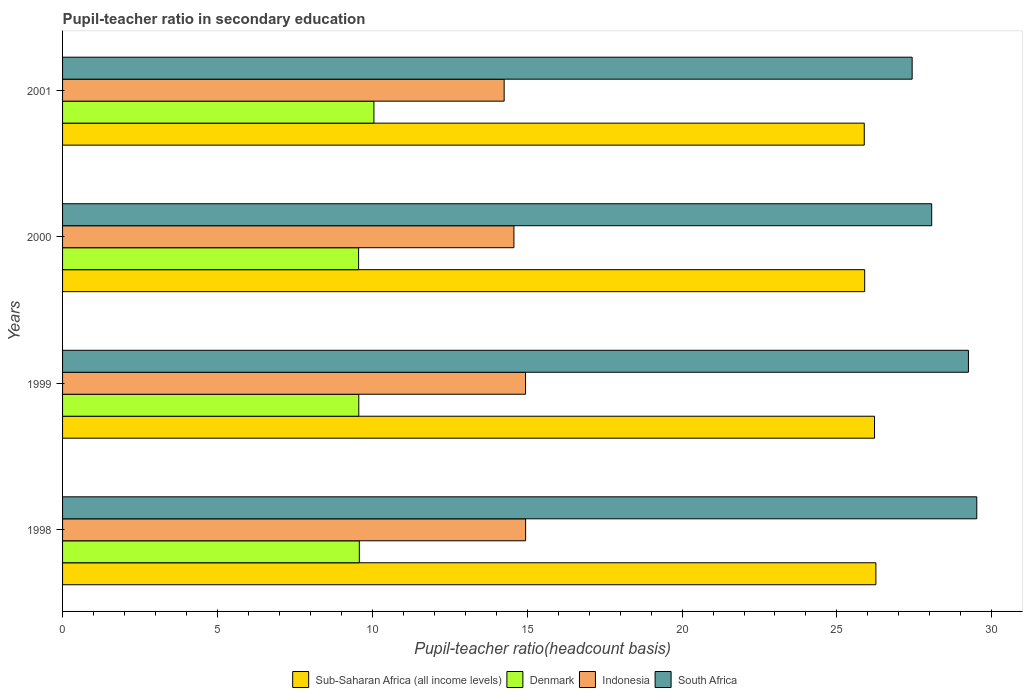How many groups of bars are there?
Keep it short and to the point. 4. Are the number of bars on each tick of the Y-axis equal?
Make the answer very short. Yes. How many bars are there on the 4th tick from the top?
Offer a terse response. 4. How many bars are there on the 2nd tick from the bottom?
Offer a terse response. 4. What is the pupil-teacher ratio in secondary education in Sub-Saharan Africa (all income levels) in 2001?
Provide a succinct answer. 25.88. Across all years, what is the maximum pupil-teacher ratio in secondary education in Indonesia?
Provide a succinct answer. 14.95. Across all years, what is the minimum pupil-teacher ratio in secondary education in Denmark?
Make the answer very short. 9.56. In which year was the pupil-teacher ratio in secondary education in Sub-Saharan Africa (all income levels) maximum?
Your answer should be compact. 1998. What is the total pupil-teacher ratio in secondary education in South Africa in the graph?
Provide a succinct answer. 114.25. What is the difference between the pupil-teacher ratio in secondary education in Sub-Saharan Africa (all income levels) in 1998 and that in 2000?
Make the answer very short. 0.36. What is the difference between the pupil-teacher ratio in secondary education in Indonesia in 2000 and the pupil-teacher ratio in secondary education in South Africa in 2001?
Provide a short and direct response. -12.86. What is the average pupil-teacher ratio in secondary education in Denmark per year?
Your answer should be compact. 9.69. In the year 1999, what is the difference between the pupil-teacher ratio in secondary education in South Africa and pupil-teacher ratio in secondary education in Sub-Saharan Africa (all income levels)?
Your answer should be very brief. 3.03. In how many years, is the pupil-teacher ratio in secondary education in Indonesia greater than 27 ?
Give a very brief answer. 0. What is the ratio of the pupil-teacher ratio in secondary education in Indonesia in 1998 to that in 2000?
Your answer should be very brief. 1.03. Is the pupil-teacher ratio in secondary education in Indonesia in 1999 less than that in 2000?
Offer a terse response. No. What is the difference between the highest and the second highest pupil-teacher ratio in secondary education in South Africa?
Ensure brevity in your answer.  0.27. What is the difference between the highest and the lowest pupil-teacher ratio in secondary education in Sub-Saharan Africa (all income levels)?
Your answer should be compact. 0.38. In how many years, is the pupil-teacher ratio in secondary education in Indonesia greater than the average pupil-teacher ratio in secondary education in Indonesia taken over all years?
Offer a terse response. 2. What does the 4th bar from the top in 2000 represents?
Ensure brevity in your answer.  Sub-Saharan Africa (all income levels). What does the 4th bar from the bottom in 2001 represents?
Your answer should be compact. South Africa. Is it the case that in every year, the sum of the pupil-teacher ratio in secondary education in Denmark and pupil-teacher ratio in secondary education in Sub-Saharan Africa (all income levels) is greater than the pupil-teacher ratio in secondary education in South Africa?
Provide a short and direct response. Yes. How many years are there in the graph?
Your answer should be very brief. 4. What is the difference between two consecutive major ticks on the X-axis?
Your response must be concise. 5. Are the values on the major ticks of X-axis written in scientific E-notation?
Offer a very short reply. No. How many legend labels are there?
Keep it short and to the point. 4. How are the legend labels stacked?
Your answer should be compact. Horizontal. What is the title of the graph?
Your answer should be very brief. Pupil-teacher ratio in secondary education. What is the label or title of the X-axis?
Make the answer very short. Pupil-teacher ratio(headcount basis). What is the Pupil-teacher ratio(headcount basis) of Sub-Saharan Africa (all income levels) in 1998?
Your answer should be very brief. 26.26. What is the Pupil-teacher ratio(headcount basis) of Denmark in 1998?
Your response must be concise. 9.58. What is the Pupil-teacher ratio(headcount basis) in Indonesia in 1998?
Your answer should be compact. 14.95. What is the Pupil-teacher ratio(headcount basis) in South Africa in 1998?
Your response must be concise. 29.52. What is the Pupil-teacher ratio(headcount basis) of Sub-Saharan Africa (all income levels) in 1999?
Your answer should be compact. 26.21. What is the Pupil-teacher ratio(headcount basis) in Denmark in 1999?
Give a very brief answer. 9.56. What is the Pupil-teacher ratio(headcount basis) in Indonesia in 1999?
Offer a terse response. 14.95. What is the Pupil-teacher ratio(headcount basis) in South Africa in 1999?
Your answer should be compact. 29.25. What is the Pupil-teacher ratio(headcount basis) of Sub-Saharan Africa (all income levels) in 2000?
Give a very brief answer. 25.9. What is the Pupil-teacher ratio(headcount basis) in Denmark in 2000?
Your response must be concise. 9.56. What is the Pupil-teacher ratio(headcount basis) of Indonesia in 2000?
Ensure brevity in your answer.  14.57. What is the Pupil-teacher ratio(headcount basis) of South Africa in 2000?
Provide a succinct answer. 28.06. What is the Pupil-teacher ratio(headcount basis) in Sub-Saharan Africa (all income levels) in 2001?
Offer a very short reply. 25.88. What is the Pupil-teacher ratio(headcount basis) in Denmark in 2001?
Keep it short and to the point. 10.05. What is the Pupil-teacher ratio(headcount basis) in Indonesia in 2001?
Keep it short and to the point. 14.26. What is the Pupil-teacher ratio(headcount basis) of South Africa in 2001?
Offer a terse response. 27.43. Across all years, what is the maximum Pupil-teacher ratio(headcount basis) in Sub-Saharan Africa (all income levels)?
Keep it short and to the point. 26.26. Across all years, what is the maximum Pupil-teacher ratio(headcount basis) of Denmark?
Keep it short and to the point. 10.05. Across all years, what is the maximum Pupil-teacher ratio(headcount basis) of Indonesia?
Your answer should be very brief. 14.95. Across all years, what is the maximum Pupil-teacher ratio(headcount basis) of South Africa?
Your response must be concise. 29.52. Across all years, what is the minimum Pupil-teacher ratio(headcount basis) in Sub-Saharan Africa (all income levels)?
Ensure brevity in your answer.  25.88. Across all years, what is the minimum Pupil-teacher ratio(headcount basis) in Denmark?
Provide a short and direct response. 9.56. Across all years, what is the minimum Pupil-teacher ratio(headcount basis) in Indonesia?
Make the answer very short. 14.26. Across all years, what is the minimum Pupil-teacher ratio(headcount basis) in South Africa?
Ensure brevity in your answer.  27.43. What is the total Pupil-teacher ratio(headcount basis) in Sub-Saharan Africa (all income levels) in the graph?
Provide a succinct answer. 104.25. What is the total Pupil-teacher ratio(headcount basis) in Denmark in the graph?
Offer a very short reply. 38.75. What is the total Pupil-teacher ratio(headcount basis) of Indonesia in the graph?
Make the answer very short. 58.73. What is the total Pupil-teacher ratio(headcount basis) of South Africa in the graph?
Provide a succinct answer. 114.25. What is the difference between the Pupil-teacher ratio(headcount basis) in Sub-Saharan Africa (all income levels) in 1998 and that in 1999?
Make the answer very short. 0.04. What is the difference between the Pupil-teacher ratio(headcount basis) in Denmark in 1998 and that in 1999?
Your answer should be compact. 0.02. What is the difference between the Pupil-teacher ratio(headcount basis) of Indonesia in 1998 and that in 1999?
Provide a short and direct response. 0. What is the difference between the Pupil-teacher ratio(headcount basis) of South Africa in 1998 and that in 1999?
Give a very brief answer. 0.27. What is the difference between the Pupil-teacher ratio(headcount basis) in Sub-Saharan Africa (all income levels) in 1998 and that in 2000?
Give a very brief answer. 0.36. What is the difference between the Pupil-teacher ratio(headcount basis) in Denmark in 1998 and that in 2000?
Your response must be concise. 0.02. What is the difference between the Pupil-teacher ratio(headcount basis) of Indonesia in 1998 and that in 2000?
Provide a short and direct response. 0.38. What is the difference between the Pupil-teacher ratio(headcount basis) of South Africa in 1998 and that in 2000?
Your answer should be compact. 1.46. What is the difference between the Pupil-teacher ratio(headcount basis) in Sub-Saharan Africa (all income levels) in 1998 and that in 2001?
Offer a terse response. 0.38. What is the difference between the Pupil-teacher ratio(headcount basis) of Denmark in 1998 and that in 2001?
Keep it short and to the point. -0.47. What is the difference between the Pupil-teacher ratio(headcount basis) of Indonesia in 1998 and that in 2001?
Keep it short and to the point. 0.69. What is the difference between the Pupil-teacher ratio(headcount basis) of South Africa in 1998 and that in 2001?
Keep it short and to the point. 2.09. What is the difference between the Pupil-teacher ratio(headcount basis) of Sub-Saharan Africa (all income levels) in 1999 and that in 2000?
Ensure brevity in your answer.  0.32. What is the difference between the Pupil-teacher ratio(headcount basis) in Denmark in 1999 and that in 2000?
Provide a succinct answer. 0.01. What is the difference between the Pupil-teacher ratio(headcount basis) in Indonesia in 1999 and that in 2000?
Provide a short and direct response. 0.38. What is the difference between the Pupil-teacher ratio(headcount basis) of South Africa in 1999 and that in 2000?
Your answer should be compact. 1.19. What is the difference between the Pupil-teacher ratio(headcount basis) of Sub-Saharan Africa (all income levels) in 1999 and that in 2001?
Provide a short and direct response. 0.33. What is the difference between the Pupil-teacher ratio(headcount basis) in Denmark in 1999 and that in 2001?
Keep it short and to the point. -0.49. What is the difference between the Pupil-teacher ratio(headcount basis) of Indonesia in 1999 and that in 2001?
Your answer should be very brief. 0.69. What is the difference between the Pupil-teacher ratio(headcount basis) of South Africa in 1999 and that in 2001?
Your response must be concise. 1.82. What is the difference between the Pupil-teacher ratio(headcount basis) in Sub-Saharan Africa (all income levels) in 2000 and that in 2001?
Your answer should be compact. 0.01. What is the difference between the Pupil-teacher ratio(headcount basis) in Denmark in 2000 and that in 2001?
Offer a very short reply. -0.49. What is the difference between the Pupil-teacher ratio(headcount basis) in Indonesia in 2000 and that in 2001?
Ensure brevity in your answer.  0.32. What is the difference between the Pupil-teacher ratio(headcount basis) of South Africa in 2000 and that in 2001?
Your response must be concise. 0.63. What is the difference between the Pupil-teacher ratio(headcount basis) in Sub-Saharan Africa (all income levels) in 1998 and the Pupil-teacher ratio(headcount basis) in Denmark in 1999?
Your answer should be compact. 16.69. What is the difference between the Pupil-teacher ratio(headcount basis) in Sub-Saharan Africa (all income levels) in 1998 and the Pupil-teacher ratio(headcount basis) in Indonesia in 1999?
Your answer should be compact. 11.31. What is the difference between the Pupil-teacher ratio(headcount basis) in Sub-Saharan Africa (all income levels) in 1998 and the Pupil-teacher ratio(headcount basis) in South Africa in 1999?
Your answer should be compact. -2.99. What is the difference between the Pupil-teacher ratio(headcount basis) of Denmark in 1998 and the Pupil-teacher ratio(headcount basis) of Indonesia in 1999?
Ensure brevity in your answer.  -5.37. What is the difference between the Pupil-teacher ratio(headcount basis) of Denmark in 1998 and the Pupil-teacher ratio(headcount basis) of South Africa in 1999?
Offer a very short reply. -19.67. What is the difference between the Pupil-teacher ratio(headcount basis) in Indonesia in 1998 and the Pupil-teacher ratio(headcount basis) in South Africa in 1999?
Give a very brief answer. -14.3. What is the difference between the Pupil-teacher ratio(headcount basis) in Sub-Saharan Africa (all income levels) in 1998 and the Pupil-teacher ratio(headcount basis) in Denmark in 2000?
Give a very brief answer. 16.7. What is the difference between the Pupil-teacher ratio(headcount basis) in Sub-Saharan Africa (all income levels) in 1998 and the Pupil-teacher ratio(headcount basis) in Indonesia in 2000?
Make the answer very short. 11.69. What is the difference between the Pupil-teacher ratio(headcount basis) in Sub-Saharan Africa (all income levels) in 1998 and the Pupil-teacher ratio(headcount basis) in South Africa in 2000?
Offer a terse response. -1.8. What is the difference between the Pupil-teacher ratio(headcount basis) of Denmark in 1998 and the Pupil-teacher ratio(headcount basis) of Indonesia in 2000?
Make the answer very short. -4.99. What is the difference between the Pupil-teacher ratio(headcount basis) in Denmark in 1998 and the Pupil-teacher ratio(headcount basis) in South Africa in 2000?
Ensure brevity in your answer.  -18.48. What is the difference between the Pupil-teacher ratio(headcount basis) of Indonesia in 1998 and the Pupil-teacher ratio(headcount basis) of South Africa in 2000?
Your answer should be very brief. -13.11. What is the difference between the Pupil-teacher ratio(headcount basis) in Sub-Saharan Africa (all income levels) in 1998 and the Pupil-teacher ratio(headcount basis) in Denmark in 2001?
Your answer should be compact. 16.21. What is the difference between the Pupil-teacher ratio(headcount basis) in Sub-Saharan Africa (all income levels) in 1998 and the Pupil-teacher ratio(headcount basis) in Indonesia in 2001?
Ensure brevity in your answer.  12. What is the difference between the Pupil-teacher ratio(headcount basis) in Sub-Saharan Africa (all income levels) in 1998 and the Pupil-teacher ratio(headcount basis) in South Africa in 2001?
Ensure brevity in your answer.  -1.17. What is the difference between the Pupil-teacher ratio(headcount basis) of Denmark in 1998 and the Pupil-teacher ratio(headcount basis) of Indonesia in 2001?
Provide a short and direct response. -4.68. What is the difference between the Pupil-teacher ratio(headcount basis) of Denmark in 1998 and the Pupil-teacher ratio(headcount basis) of South Africa in 2001?
Your answer should be very brief. -17.85. What is the difference between the Pupil-teacher ratio(headcount basis) in Indonesia in 1998 and the Pupil-teacher ratio(headcount basis) in South Africa in 2001?
Offer a very short reply. -12.48. What is the difference between the Pupil-teacher ratio(headcount basis) of Sub-Saharan Africa (all income levels) in 1999 and the Pupil-teacher ratio(headcount basis) of Denmark in 2000?
Your answer should be very brief. 16.66. What is the difference between the Pupil-teacher ratio(headcount basis) in Sub-Saharan Africa (all income levels) in 1999 and the Pupil-teacher ratio(headcount basis) in Indonesia in 2000?
Provide a short and direct response. 11.64. What is the difference between the Pupil-teacher ratio(headcount basis) in Sub-Saharan Africa (all income levels) in 1999 and the Pupil-teacher ratio(headcount basis) in South Africa in 2000?
Your answer should be very brief. -1.85. What is the difference between the Pupil-teacher ratio(headcount basis) in Denmark in 1999 and the Pupil-teacher ratio(headcount basis) in Indonesia in 2000?
Your answer should be very brief. -5.01. What is the difference between the Pupil-teacher ratio(headcount basis) in Denmark in 1999 and the Pupil-teacher ratio(headcount basis) in South Africa in 2000?
Offer a terse response. -18.5. What is the difference between the Pupil-teacher ratio(headcount basis) in Indonesia in 1999 and the Pupil-teacher ratio(headcount basis) in South Africa in 2000?
Offer a terse response. -13.11. What is the difference between the Pupil-teacher ratio(headcount basis) in Sub-Saharan Africa (all income levels) in 1999 and the Pupil-teacher ratio(headcount basis) in Denmark in 2001?
Provide a succinct answer. 16.16. What is the difference between the Pupil-teacher ratio(headcount basis) of Sub-Saharan Africa (all income levels) in 1999 and the Pupil-teacher ratio(headcount basis) of Indonesia in 2001?
Offer a terse response. 11.96. What is the difference between the Pupil-teacher ratio(headcount basis) in Sub-Saharan Africa (all income levels) in 1999 and the Pupil-teacher ratio(headcount basis) in South Africa in 2001?
Give a very brief answer. -1.22. What is the difference between the Pupil-teacher ratio(headcount basis) of Denmark in 1999 and the Pupil-teacher ratio(headcount basis) of Indonesia in 2001?
Provide a succinct answer. -4.69. What is the difference between the Pupil-teacher ratio(headcount basis) in Denmark in 1999 and the Pupil-teacher ratio(headcount basis) in South Africa in 2001?
Keep it short and to the point. -17.87. What is the difference between the Pupil-teacher ratio(headcount basis) in Indonesia in 1999 and the Pupil-teacher ratio(headcount basis) in South Africa in 2001?
Provide a succinct answer. -12.48. What is the difference between the Pupil-teacher ratio(headcount basis) of Sub-Saharan Africa (all income levels) in 2000 and the Pupil-teacher ratio(headcount basis) of Denmark in 2001?
Provide a short and direct response. 15.84. What is the difference between the Pupil-teacher ratio(headcount basis) of Sub-Saharan Africa (all income levels) in 2000 and the Pupil-teacher ratio(headcount basis) of Indonesia in 2001?
Provide a short and direct response. 11.64. What is the difference between the Pupil-teacher ratio(headcount basis) of Sub-Saharan Africa (all income levels) in 2000 and the Pupil-teacher ratio(headcount basis) of South Africa in 2001?
Keep it short and to the point. -1.53. What is the difference between the Pupil-teacher ratio(headcount basis) in Denmark in 2000 and the Pupil-teacher ratio(headcount basis) in Indonesia in 2001?
Provide a succinct answer. -4.7. What is the difference between the Pupil-teacher ratio(headcount basis) of Denmark in 2000 and the Pupil-teacher ratio(headcount basis) of South Africa in 2001?
Make the answer very short. -17.87. What is the difference between the Pupil-teacher ratio(headcount basis) of Indonesia in 2000 and the Pupil-teacher ratio(headcount basis) of South Africa in 2001?
Ensure brevity in your answer.  -12.86. What is the average Pupil-teacher ratio(headcount basis) in Sub-Saharan Africa (all income levels) per year?
Your answer should be compact. 26.06. What is the average Pupil-teacher ratio(headcount basis) of Denmark per year?
Ensure brevity in your answer.  9.69. What is the average Pupil-teacher ratio(headcount basis) in Indonesia per year?
Your answer should be very brief. 14.68. What is the average Pupil-teacher ratio(headcount basis) in South Africa per year?
Offer a very short reply. 28.56. In the year 1998, what is the difference between the Pupil-teacher ratio(headcount basis) of Sub-Saharan Africa (all income levels) and Pupil-teacher ratio(headcount basis) of Denmark?
Give a very brief answer. 16.68. In the year 1998, what is the difference between the Pupil-teacher ratio(headcount basis) of Sub-Saharan Africa (all income levels) and Pupil-teacher ratio(headcount basis) of Indonesia?
Give a very brief answer. 11.31. In the year 1998, what is the difference between the Pupil-teacher ratio(headcount basis) in Sub-Saharan Africa (all income levels) and Pupil-teacher ratio(headcount basis) in South Africa?
Provide a short and direct response. -3.26. In the year 1998, what is the difference between the Pupil-teacher ratio(headcount basis) in Denmark and Pupil-teacher ratio(headcount basis) in Indonesia?
Provide a short and direct response. -5.37. In the year 1998, what is the difference between the Pupil-teacher ratio(headcount basis) in Denmark and Pupil-teacher ratio(headcount basis) in South Africa?
Your answer should be compact. -19.93. In the year 1998, what is the difference between the Pupil-teacher ratio(headcount basis) in Indonesia and Pupil-teacher ratio(headcount basis) in South Africa?
Your answer should be very brief. -14.57. In the year 1999, what is the difference between the Pupil-teacher ratio(headcount basis) in Sub-Saharan Africa (all income levels) and Pupil-teacher ratio(headcount basis) in Denmark?
Ensure brevity in your answer.  16.65. In the year 1999, what is the difference between the Pupil-teacher ratio(headcount basis) of Sub-Saharan Africa (all income levels) and Pupil-teacher ratio(headcount basis) of Indonesia?
Your answer should be compact. 11.27. In the year 1999, what is the difference between the Pupil-teacher ratio(headcount basis) in Sub-Saharan Africa (all income levels) and Pupil-teacher ratio(headcount basis) in South Africa?
Ensure brevity in your answer.  -3.03. In the year 1999, what is the difference between the Pupil-teacher ratio(headcount basis) of Denmark and Pupil-teacher ratio(headcount basis) of Indonesia?
Your answer should be very brief. -5.38. In the year 1999, what is the difference between the Pupil-teacher ratio(headcount basis) in Denmark and Pupil-teacher ratio(headcount basis) in South Africa?
Your answer should be very brief. -19.68. In the year 1999, what is the difference between the Pupil-teacher ratio(headcount basis) in Indonesia and Pupil-teacher ratio(headcount basis) in South Africa?
Give a very brief answer. -14.3. In the year 2000, what is the difference between the Pupil-teacher ratio(headcount basis) in Sub-Saharan Africa (all income levels) and Pupil-teacher ratio(headcount basis) in Denmark?
Provide a succinct answer. 16.34. In the year 2000, what is the difference between the Pupil-teacher ratio(headcount basis) in Sub-Saharan Africa (all income levels) and Pupil-teacher ratio(headcount basis) in Indonesia?
Offer a very short reply. 11.32. In the year 2000, what is the difference between the Pupil-teacher ratio(headcount basis) in Sub-Saharan Africa (all income levels) and Pupil-teacher ratio(headcount basis) in South Africa?
Offer a very short reply. -2.16. In the year 2000, what is the difference between the Pupil-teacher ratio(headcount basis) of Denmark and Pupil-teacher ratio(headcount basis) of Indonesia?
Offer a very short reply. -5.01. In the year 2000, what is the difference between the Pupil-teacher ratio(headcount basis) of Denmark and Pupil-teacher ratio(headcount basis) of South Africa?
Make the answer very short. -18.5. In the year 2000, what is the difference between the Pupil-teacher ratio(headcount basis) in Indonesia and Pupil-teacher ratio(headcount basis) in South Africa?
Keep it short and to the point. -13.49. In the year 2001, what is the difference between the Pupil-teacher ratio(headcount basis) in Sub-Saharan Africa (all income levels) and Pupil-teacher ratio(headcount basis) in Denmark?
Give a very brief answer. 15.83. In the year 2001, what is the difference between the Pupil-teacher ratio(headcount basis) of Sub-Saharan Africa (all income levels) and Pupil-teacher ratio(headcount basis) of Indonesia?
Offer a terse response. 11.63. In the year 2001, what is the difference between the Pupil-teacher ratio(headcount basis) in Sub-Saharan Africa (all income levels) and Pupil-teacher ratio(headcount basis) in South Africa?
Your response must be concise. -1.55. In the year 2001, what is the difference between the Pupil-teacher ratio(headcount basis) in Denmark and Pupil-teacher ratio(headcount basis) in Indonesia?
Make the answer very short. -4.2. In the year 2001, what is the difference between the Pupil-teacher ratio(headcount basis) of Denmark and Pupil-teacher ratio(headcount basis) of South Africa?
Keep it short and to the point. -17.38. In the year 2001, what is the difference between the Pupil-teacher ratio(headcount basis) of Indonesia and Pupil-teacher ratio(headcount basis) of South Africa?
Provide a succinct answer. -13.17. What is the ratio of the Pupil-teacher ratio(headcount basis) in Denmark in 1998 to that in 1999?
Your response must be concise. 1. What is the ratio of the Pupil-teacher ratio(headcount basis) of Indonesia in 1998 to that in 1999?
Offer a terse response. 1. What is the ratio of the Pupil-teacher ratio(headcount basis) of South Africa in 1998 to that in 1999?
Provide a short and direct response. 1.01. What is the ratio of the Pupil-teacher ratio(headcount basis) of Sub-Saharan Africa (all income levels) in 1998 to that in 2000?
Keep it short and to the point. 1.01. What is the ratio of the Pupil-teacher ratio(headcount basis) of Denmark in 1998 to that in 2000?
Ensure brevity in your answer.  1. What is the ratio of the Pupil-teacher ratio(headcount basis) in Indonesia in 1998 to that in 2000?
Give a very brief answer. 1.03. What is the ratio of the Pupil-teacher ratio(headcount basis) of South Africa in 1998 to that in 2000?
Offer a terse response. 1.05. What is the ratio of the Pupil-teacher ratio(headcount basis) of Sub-Saharan Africa (all income levels) in 1998 to that in 2001?
Give a very brief answer. 1.01. What is the ratio of the Pupil-teacher ratio(headcount basis) in Denmark in 1998 to that in 2001?
Provide a short and direct response. 0.95. What is the ratio of the Pupil-teacher ratio(headcount basis) in Indonesia in 1998 to that in 2001?
Your response must be concise. 1.05. What is the ratio of the Pupil-teacher ratio(headcount basis) in South Africa in 1998 to that in 2001?
Give a very brief answer. 1.08. What is the ratio of the Pupil-teacher ratio(headcount basis) of Sub-Saharan Africa (all income levels) in 1999 to that in 2000?
Offer a very short reply. 1.01. What is the ratio of the Pupil-teacher ratio(headcount basis) in Indonesia in 1999 to that in 2000?
Keep it short and to the point. 1.03. What is the ratio of the Pupil-teacher ratio(headcount basis) in South Africa in 1999 to that in 2000?
Offer a very short reply. 1.04. What is the ratio of the Pupil-teacher ratio(headcount basis) of Sub-Saharan Africa (all income levels) in 1999 to that in 2001?
Keep it short and to the point. 1.01. What is the ratio of the Pupil-teacher ratio(headcount basis) in Denmark in 1999 to that in 2001?
Your response must be concise. 0.95. What is the ratio of the Pupil-teacher ratio(headcount basis) of Indonesia in 1999 to that in 2001?
Provide a succinct answer. 1.05. What is the ratio of the Pupil-teacher ratio(headcount basis) of South Africa in 1999 to that in 2001?
Offer a terse response. 1.07. What is the ratio of the Pupil-teacher ratio(headcount basis) of Denmark in 2000 to that in 2001?
Keep it short and to the point. 0.95. What is the ratio of the Pupil-teacher ratio(headcount basis) of Indonesia in 2000 to that in 2001?
Your response must be concise. 1.02. What is the ratio of the Pupil-teacher ratio(headcount basis) in South Africa in 2000 to that in 2001?
Keep it short and to the point. 1.02. What is the difference between the highest and the second highest Pupil-teacher ratio(headcount basis) in Sub-Saharan Africa (all income levels)?
Make the answer very short. 0.04. What is the difference between the highest and the second highest Pupil-teacher ratio(headcount basis) of Denmark?
Your answer should be very brief. 0.47. What is the difference between the highest and the second highest Pupil-teacher ratio(headcount basis) in Indonesia?
Give a very brief answer. 0. What is the difference between the highest and the second highest Pupil-teacher ratio(headcount basis) in South Africa?
Offer a terse response. 0.27. What is the difference between the highest and the lowest Pupil-teacher ratio(headcount basis) in Sub-Saharan Africa (all income levels)?
Offer a terse response. 0.38. What is the difference between the highest and the lowest Pupil-teacher ratio(headcount basis) in Denmark?
Your response must be concise. 0.49. What is the difference between the highest and the lowest Pupil-teacher ratio(headcount basis) in Indonesia?
Your answer should be compact. 0.69. What is the difference between the highest and the lowest Pupil-teacher ratio(headcount basis) in South Africa?
Offer a terse response. 2.09. 